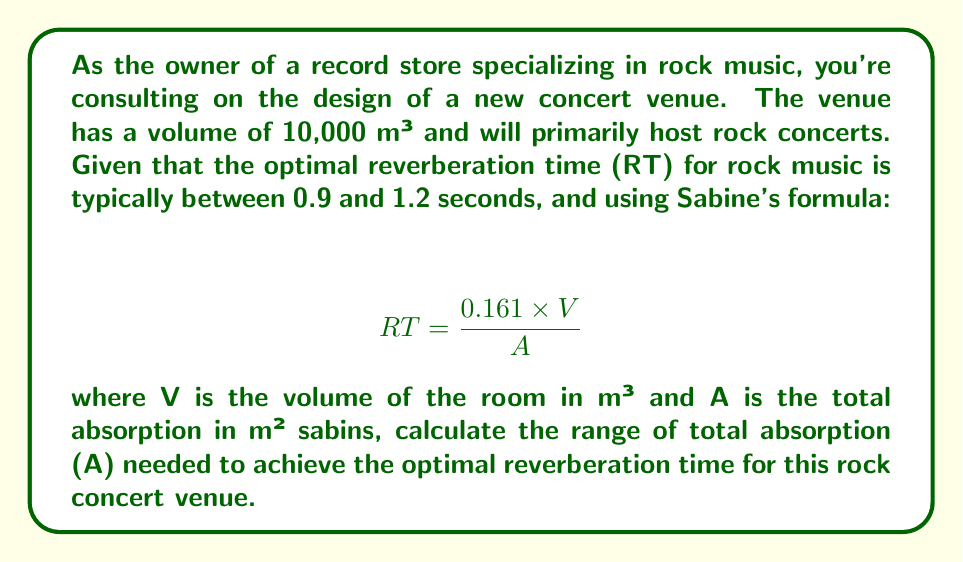Could you help me with this problem? To solve this problem, we'll use Sabine's formula and the given information:

1. Volume (V) = 10,000 m³
2. Optimal RT range for rock music: 0.9 to 1.2 seconds

We need to calculate the range of total absorption (A) that will result in the desired RT range.

Step 1: Rearrange Sabine's formula to solve for A:
$$ A = \frac{0.161 \times V}{RT} $$

Step 2: Calculate A for the lower RT limit (0.9 seconds):
$$ A_{max} = \frac{0.161 \times 10,000}{0.9} = 1788.89 \text{ m² sabins} $$

Step 3: Calculate A for the upper RT limit (1.2 seconds):
$$ A_{min} = \frac{0.161 \times 10,000}{1.2} = 1341.67 \text{ m² sabins} $$

Therefore, the range of total absorption needed is between 1341.67 and 1788.89 m² sabins.
Answer: The optimal range of total absorption (A) for the rock concert venue is 1341.67 to 1788.89 m² sabins. 